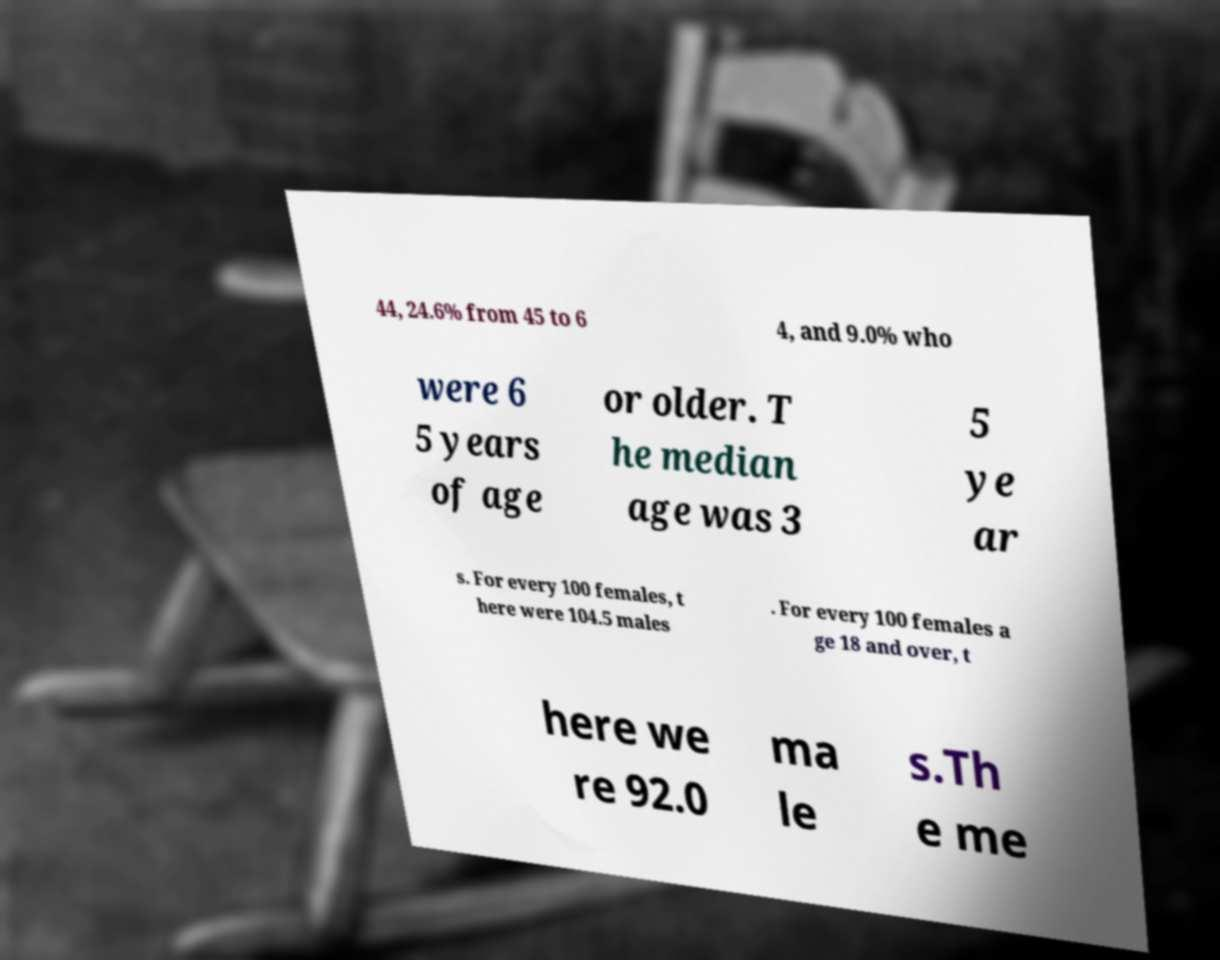Please identify and transcribe the text found in this image. 44, 24.6% from 45 to 6 4, and 9.0% who were 6 5 years of age or older. T he median age was 3 5 ye ar s. For every 100 females, t here were 104.5 males . For every 100 females a ge 18 and over, t here we re 92.0 ma le s.Th e me 